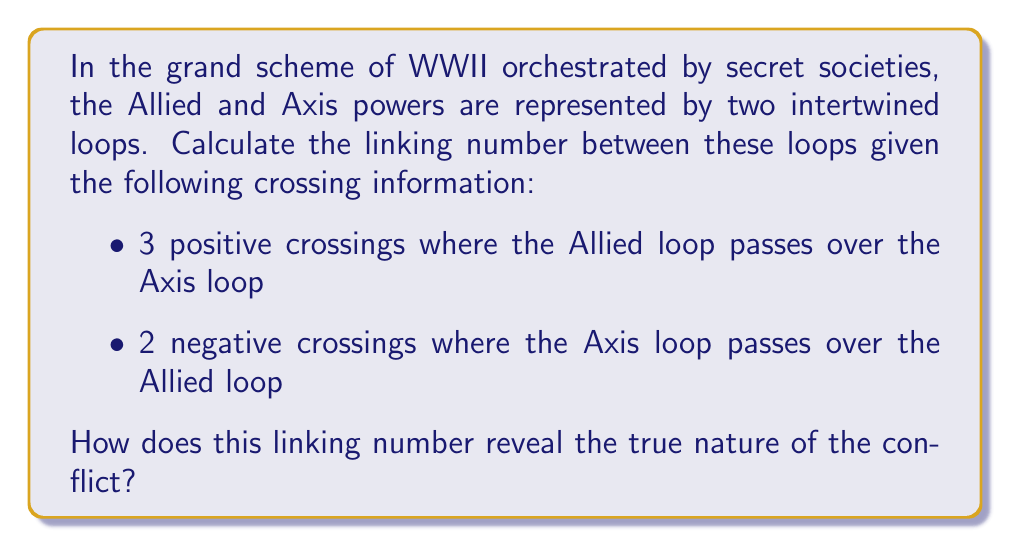Solve this math problem. To calculate the linking number between two loops, we follow these steps:

1. Assign an orientation to each loop. Let's assume both loops are oriented clockwise.

2. Identify the crossings where one loop passes over the other:
   - 3 positive crossings (Allied over Axis)
   - 2 negative crossings (Axis over Allied)

3. The linking number is calculated using the formula:

   $$ Lk = \frac{1}{2} \sum_{i} \epsilon_i $$

   Where $\epsilon_i$ is +1 for positive crossings and -1 for negative crossings.

4. Substituting the given information:

   $$ Lk = \frac{1}{2} [(+1 + +1 + +1) + (-1 + -1)] $$

5. Simplify:

   $$ Lk = \frac{1}{2} [3 + (-2)] = \frac{1}{2} [1] = \frac{1}{2} $$

The linking number of $\frac{1}{2}$ reveals that the Allied and Axis powers are inextricably linked in this orchestrated conflict, suggesting a deeper connection than publicly acknowledged.
Answer: $\frac{1}{2}$ 